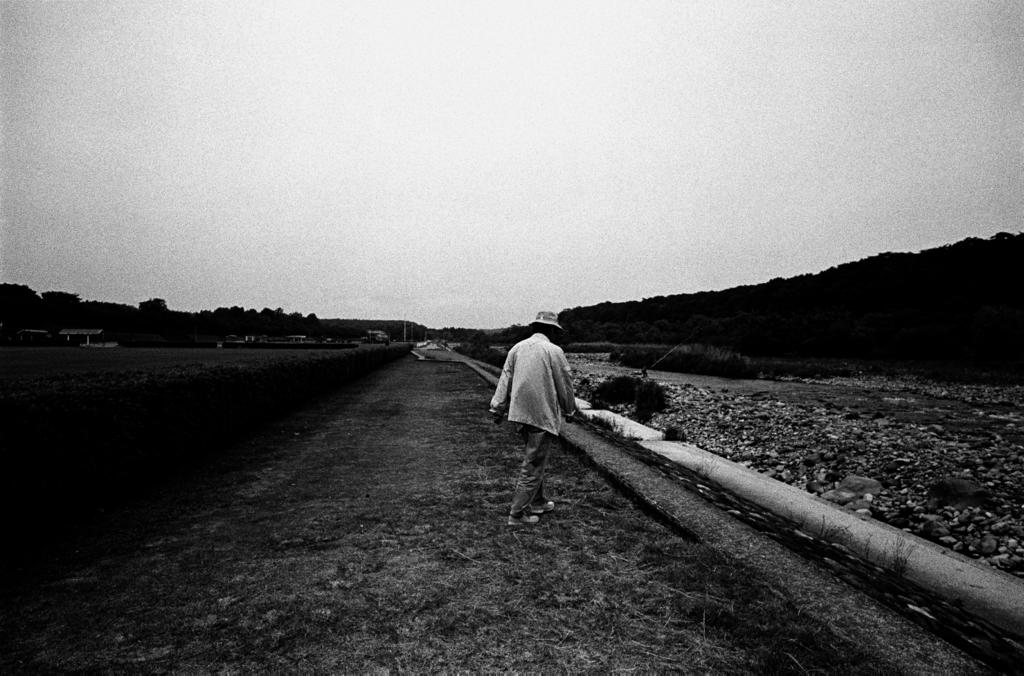What is the person in the image doing? There is a person walking on the grass in the image. What type of vegetation can be seen in the image? There are plants and trees in the image. What type of structures are visible in the image? There are houses in the image. What else can be seen in the image besides the person and vegetation? There are poles in the image. What is visible in the background of the image? The sky is visible in the background of the image. Can you see the person's son helping them walk in the image? There is no mention of a son in the image, and the person is walking independently. What type of knot is being used to secure the trees in the image? There is no knot visible in the image, as it focuses on the person walking and the surrounding environment. 